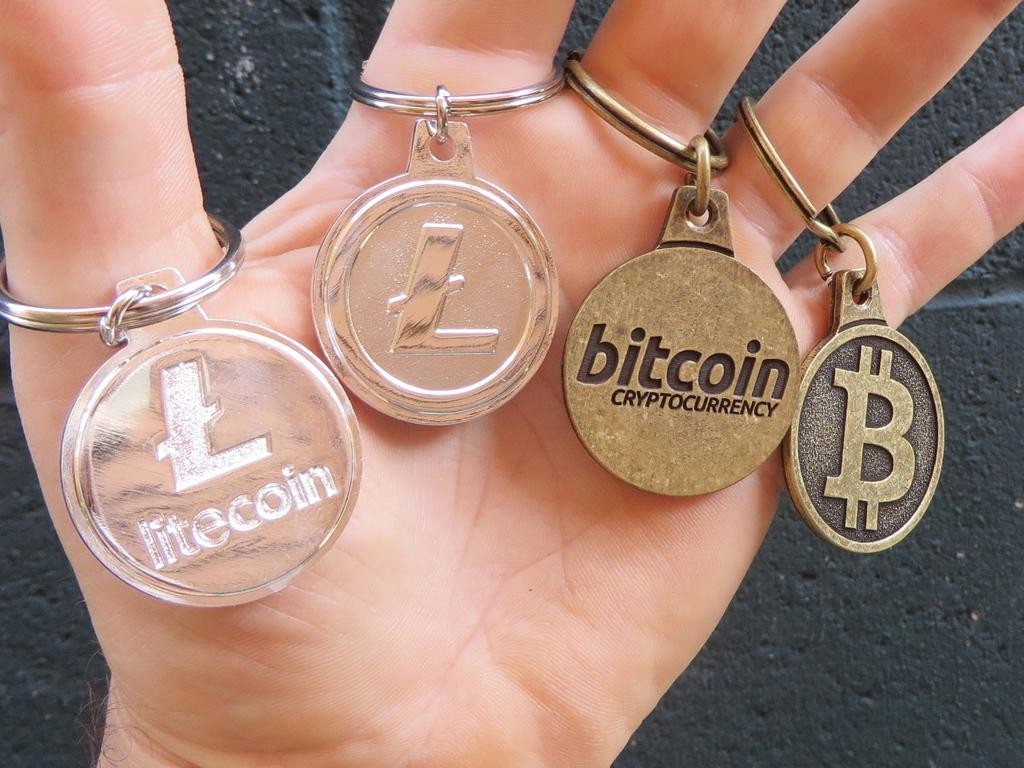<image>
Relay a brief, clear account of the picture shown. Hand holding four keychains including Bitcoin and litecoin. 